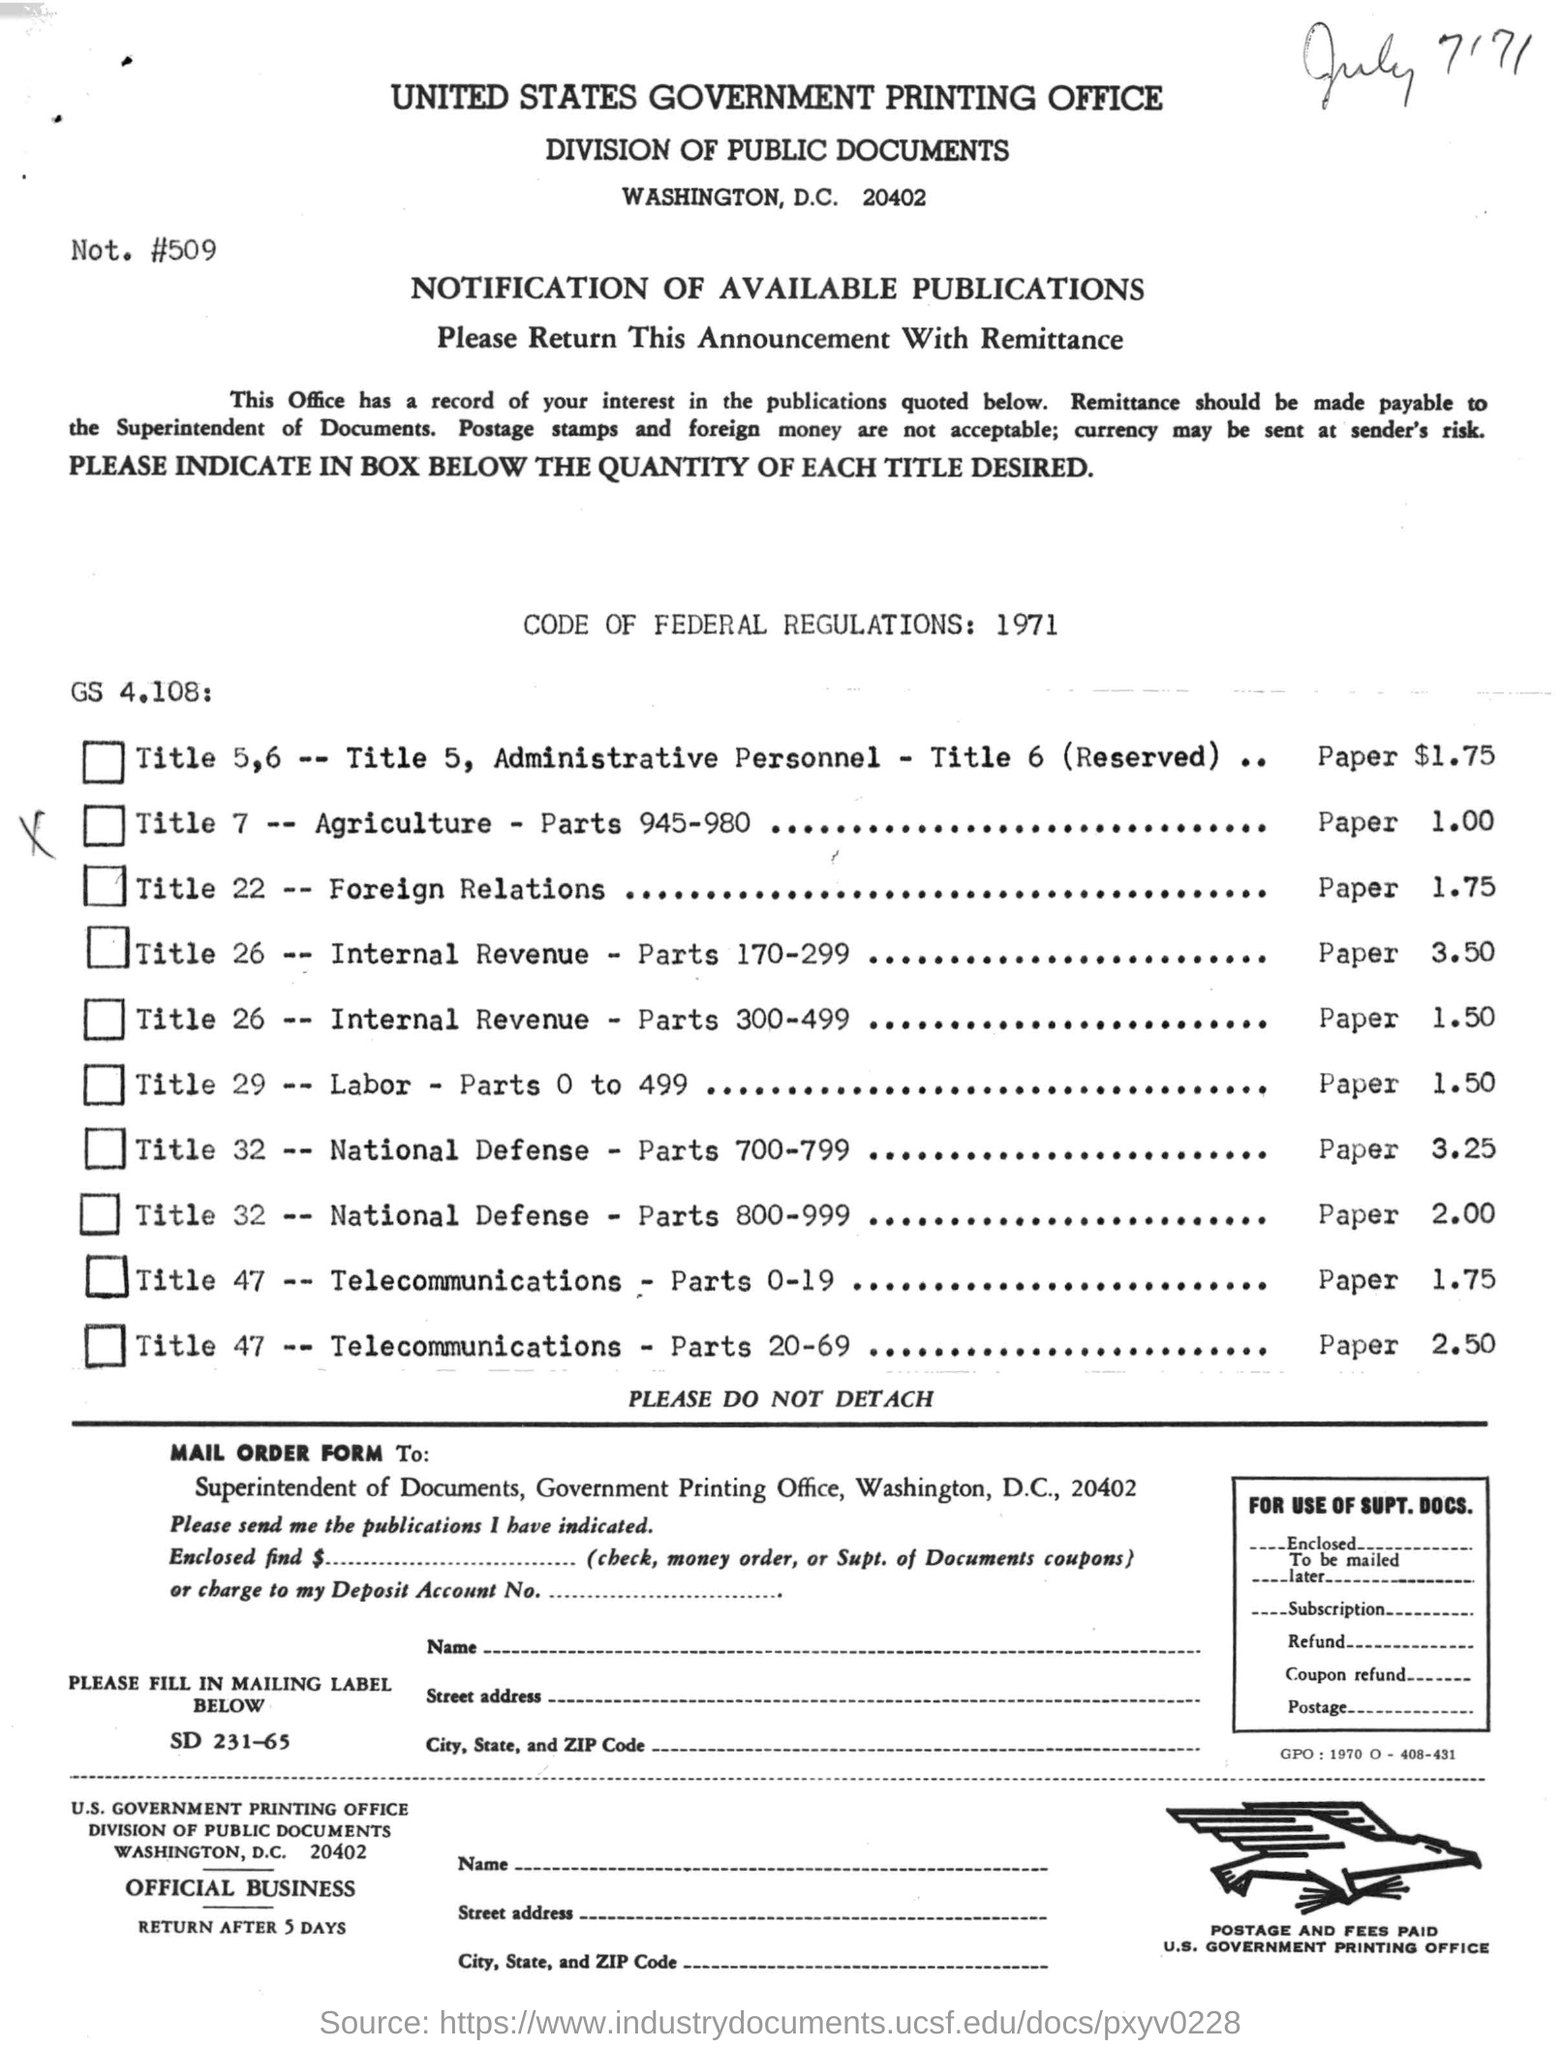What is the name of the printing office ?
Your response must be concise. United states government printing office. Under which year the code of federal regulations was written ?
Make the answer very short. 1971. 